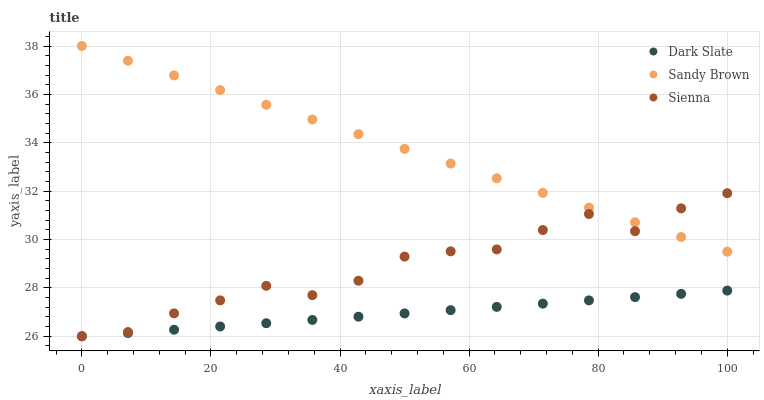Does Dark Slate have the minimum area under the curve?
Answer yes or no. Yes. Does Sandy Brown have the maximum area under the curve?
Answer yes or no. Yes. Does Sandy Brown have the minimum area under the curve?
Answer yes or no. No. Does Dark Slate have the maximum area under the curve?
Answer yes or no. No. Is Dark Slate the smoothest?
Answer yes or no. Yes. Is Sienna the roughest?
Answer yes or no. Yes. Is Sandy Brown the smoothest?
Answer yes or no. No. Is Sandy Brown the roughest?
Answer yes or no. No. Does Sienna have the lowest value?
Answer yes or no. Yes. Does Sandy Brown have the lowest value?
Answer yes or no. No. Does Sandy Brown have the highest value?
Answer yes or no. Yes. Does Dark Slate have the highest value?
Answer yes or no. No. Is Dark Slate less than Sandy Brown?
Answer yes or no. Yes. Is Sandy Brown greater than Dark Slate?
Answer yes or no. Yes. Does Sienna intersect Sandy Brown?
Answer yes or no. Yes. Is Sienna less than Sandy Brown?
Answer yes or no. No. Is Sienna greater than Sandy Brown?
Answer yes or no. No. Does Dark Slate intersect Sandy Brown?
Answer yes or no. No. 